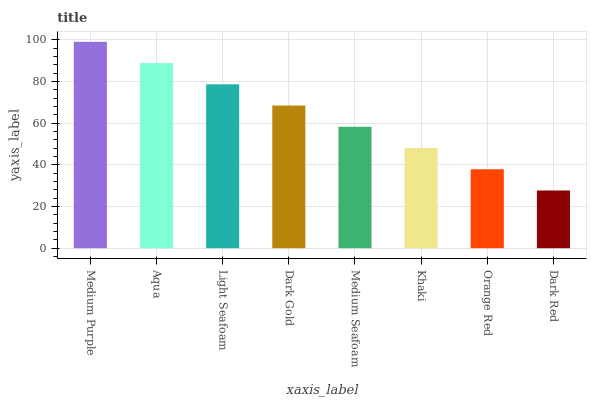Is Dark Red the minimum?
Answer yes or no. Yes. Is Medium Purple the maximum?
Answer yes or no. Yes. Is Aqua the minimum?
Answer yes or no. No. Is Aqua the maximum?
Answer yes or no. No. Is Medium Purple greater than Aqua?
Answer yes or no. Yes. Is Aqua less than Medium Purple?
Answer yes or no. Yes. Is Aqua greater than Medium Purple?
Answer yes or no. No. Is Medium Purple less than Aqua?
Answer yes or no. No. Is Dark Gold the high median?
Answer yes or no. Yes. Is Medium Seafoam the low median?
Answer yes or no. Yes. Is Medium Purple the high median?
Answer yes or no. No. Is Khaki the low median?
Answer yes or no. No. 